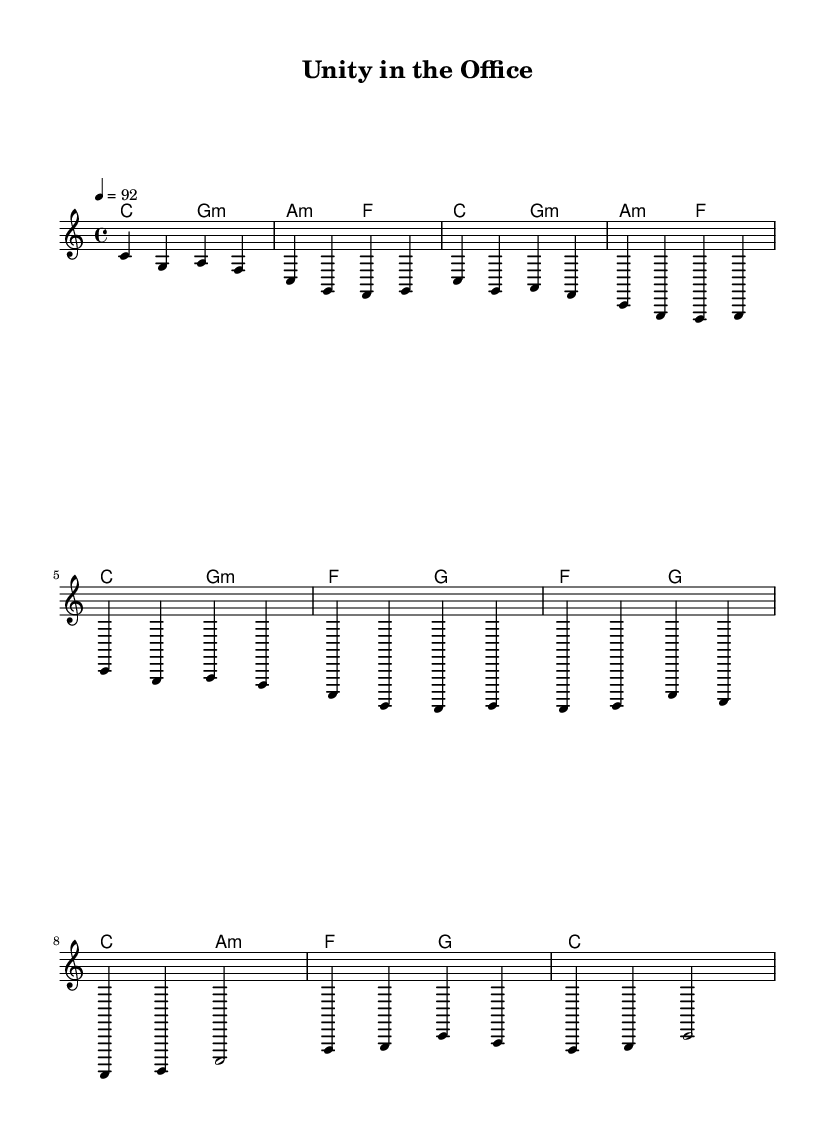What is the key signature of this music? The key signature appears at the beginning of the staff and indicates C major, which has no sharps or flats.
Answer: C major What is the time signature of this music? The time signature is located at the beginning right after the key signature, showing 4/4, which means there are four beats per measure and a quarter note gets one beat.
Answer: 4/4 What is the tempo marking of this piece? The tempo marking is indicated in beats per minute after the time signature, reading 4 equals 92, which means the piece is played at a moderate pace.
Answer: 92 How many measures are in the verse? Counting the number of measures specifically in the verse section, which includes two sets repeated, results in a total of 8 measures.
Answer: 8 What is the main theme expressed in the lyrics of the chorus? Reading the lyrics in the chorus section shows a primary message of unity and teamwork in the workplace, which emphasizes collective goals and cooperation.
Answer: Unity What is the pattern used in the harmony for the chorus? Observing the chord layout during the chorus reveals a pattern of changing chords, specifically moving from F to G and then to C and A minor, indicating progression in the music.
Answer: F, G, C, A minor What musical style is this piece? The style can be inferred from both the rhythmic patterns and the use of lyrics focused on teamwork and celebration, which are characteristic of reggae music, suggesting a vibrant, upbeat style.
Answer: Reggae 